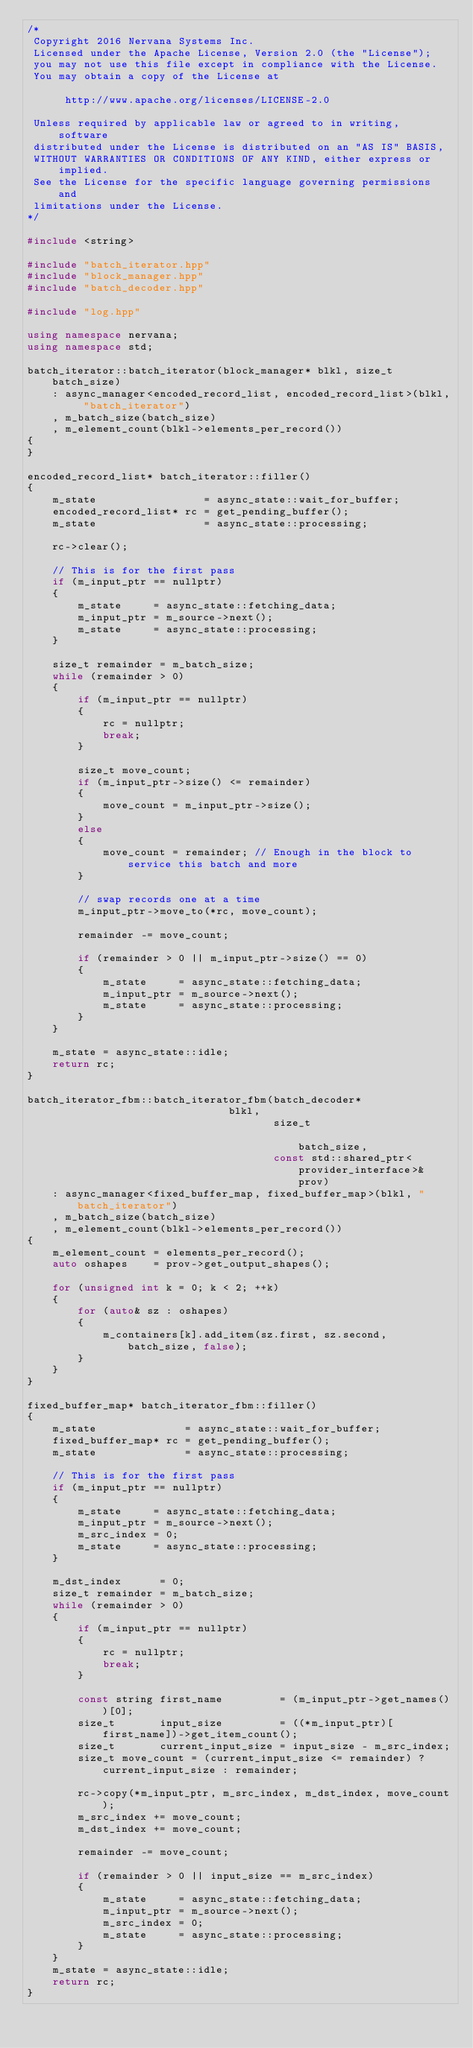<code> <loc_0><loc_0><loc_500><loc_500><_C++_>/*
 Copyright 2016 Nervana Systems Inc.
 Licensed under the Apache License, Version 2.0 (the "License");
 you may not use this file except in compliance with the License.
 You may obtain a copy of the License at

      http://www.apache.org/licenses/LICENSE-2.0

 Unless required by applicable law or agreed to in writing, software
 distributed under the License is distributed on an "AS IS" BASIS,
 WITHOUT WARRANTIES OR CONDITIONS OF ANY KIND, either express or implied.
 See the License for the specific language governing permissions and
 limitations under the License.
*/

#include <string>

#include "batch_iterator.hpp"
#include "block_manager.hpp"
#include "batch_decoder.hpp"

#include "log.hpp"

using namespace nervana;
using namespace std;

batch_iterator::batch_iterator(block_manager* blkl, size_t batch_size)
    : async_manager<encoded_record_list, encoded_record_list>(blkl, "batch_iterator")
    , m_batch_size(batch_size)
    , m_element_count(blkl->elements_per_record())
{
}

encoded_record_list* batch_iterator::filler()
{
    m_state                 = async_state::wait_for_buffer;
    encoded_record_list* rc = get_pending_buffer();
    m_state                 = async_state::processing;

    rc->clear();

    // This is for the first pass
    if (m_input_ptr == nullptr)
    {
        m_state     = async_state::fetching_data;
        m_input_ptr = m_source->next();
        m_state     = async_state::processing;
    }

    size_t remainder = m_batch_size;
    while (remainder > 0)
    {
        if (m_input_ptr == nullptr)
        {
            rc = nullptr;
            break;
        }

        size_t move_count;
        if (m_input_ptr->size() <= remainder)
        {
            move_count = m_input_ptr->size();
        }
        else
        {
            move_count = remainder; // Enough in the block to service this batch and more
        }

        // swap records one at a time
        m_input_ptr->move_to(*rc, move_count);

        remainder -= move_count;

        if (remainder > 0 || m_input_ptr->size() == 0)
        {
            m_state     = async_state::fetching_data;
            m_input_ptr = m_source->next();
            m_state     = async_state::processing;
        }
    }

    m_state = async_state::idle;
    return rc;
}

batch_iterator_fbm::batch_iterator_fbm(batch_decoder*                             blkl,
                                       size_t                                     batch_size,
                                       const std::shared_ptr<provider_interface>& prov)
    : async_manager<fixed_buffer_map, fixed_buffer_map>(blkl, "batch_iterator")
    , m_batch_size(batch_size)
    , m_element_count(blkl->elements_per_record())
{
    m_element_count = elements_per_record();
    auto oshapes    = prov->get_output_shapes();

    for (unsigned int k = 0; k < 2; ++k)
    {
        for (auto& sz : oshapes)
        {
            m_containers[k].add_item(sz.first, sz.second, batch_size, false);
        }
    }
}

fixed_buffer_map* batch_iterator_fbm::filler()
{
    m_state              = async_state::wait_for_buffer;
    fixed_buffer_map* rc = get_pending_buffer();
    m_state              = async_state::processing;

    // This is for the first pass
    if (m_input_ptr == nullptr)
    {
        m_state     = async_state::fetching_data;
        m_input_ptr = m_source->next();
        m_src_index = 0;
        m_state     = async_state::processing;
    }

    m_dst_index      = 0;
    size_t remainder = m_batch_size;
    while (remainder > 0)
    {
        if (m_input_ptr == nullptr)
        {
            rc = nullptr;
            break;
        }

        const string first_name         = (m_input_ptr->get_names())[0];
        size_t       input_size         = ((*m_input_ptr)[first_name])->get_item_count();
        size_t       current_input_size = input_size - m_src_index;
        size_t move_count = (current_input_size <= remainder) ? current_input_size : remainder;

        rc->copy(*m_input_ptr, m_src_index, m_dst_index, move_count);
        m_src_index += move_count;
        m_dst_index += move_count;

        remainder -= move_count;

        if (remainder > 0 || input_size == m_src_index)
        {
            m_state     = async_state::fetching_data;
            m_input_ptr = m_source->next();
            m_src_index = 0;
            m_state     = async_state::processing;
        }
    }
    m_state = async_state::idle;
    return rc;
}
</code> 